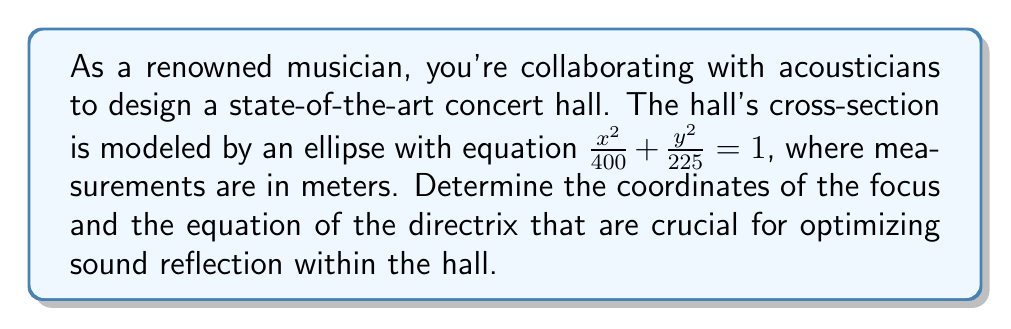Help me with this question. Let's approach this step-by-step:

1) The standard form of an ellipse equation is $\frac{x^2}{a^2} + \frac{y^2}{b^2} = 1$, where $a$ is the length of the semi-major axis and $b$ is the length of the semi-minor axis.

2) From our equation $\frac{x^2}{400} + \frac{y^2}{225} = 1$, we can deduce:
   $a^2 = 400$, so $a = 20$
   $b^2 = 225$, so $b = 15$

3) The center of the ellipse is at (0,0) as there are no terms like $(x-h)$ or $(y-k)$ in the equation.

4) To find the focal points, we use the formula $c^2 = a^2 - b^2$, where $c$ is the distance from the center to a focus:
   $c^2 = 20^2 - 15^2 = 400 - 225 = 175$
   $c = \sqrt{175} = 5\sqrt{7}$

5) Since $a > b$, the foci lie on the x-axis. Their coordinates are $(±c, 0)$:
   $(\pm 5\sqrt{7}, 0)$

6) For the directrix, we use the equation $x = ±\frac{a^2}{c}$:
   $x = ±\frac{400}{5\sqrt{7}} = ±\frac{80}{\sqrt{7}}$

7) Therefore, the equations of the directrices are:
   $x = \frac{80}{\sqrt{7}}$ and $x = -\frac{80}{\sqrt{7}}$
Answer: The coordinates of the foci are $(5\sqrt{7}, 0)$ and $(-5\sqrt{7}, 0)$.
The equations of the directrices are $x = \frac{80}{\sqrt{7}}$ and $x = -\frac{80}{\sqrt{7}}$. 